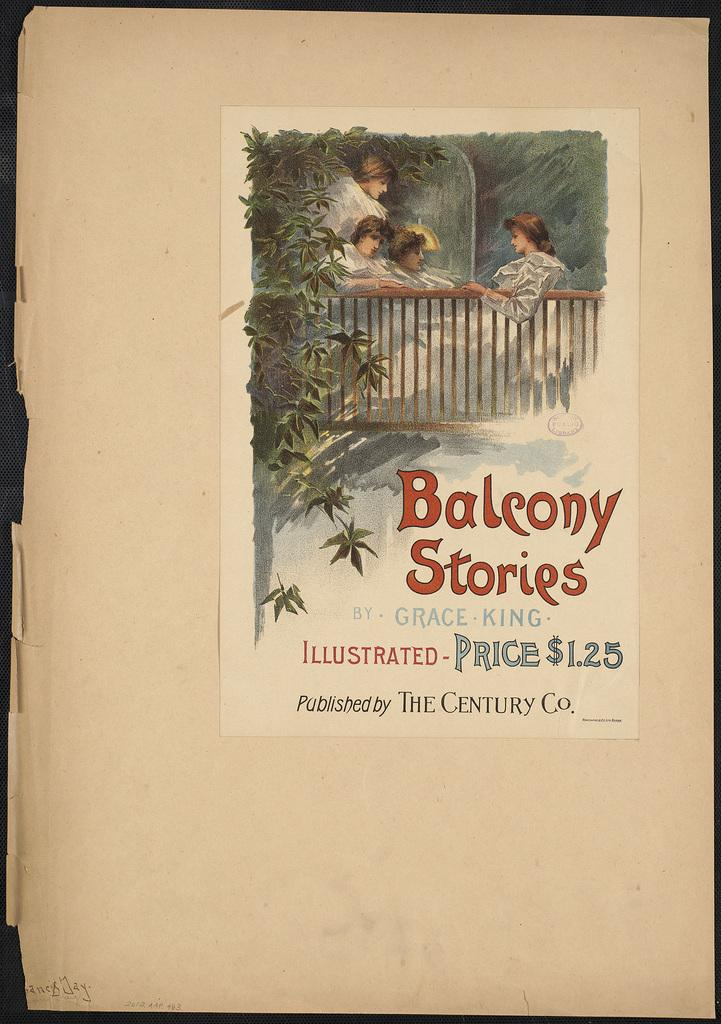<image>
Give a short and clear explanation of the subsequent image. The Balcony Stories has a price of $1.25. 